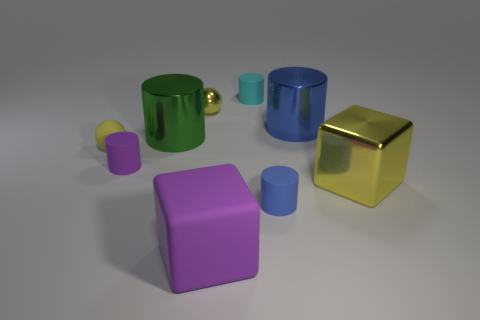How many things are either big things to the left of the tiny yellow metal sphere or blue cylinders? Upon reviewing the image, there appears to be a misunderstanding in the original answer. To clarify, there are no blue cylinders in the image. Therefore, the count for big things to the left of the tiny yellow metal sphere or blue cylinders is zero. 